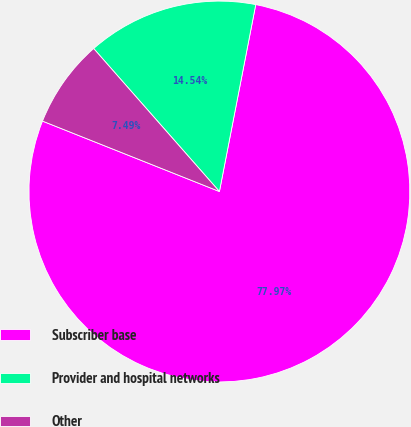<chart> <loc_0><loc_0><loc_500><loc_500><pie_chart><fcel>Subscriber base<fcel>Provider and hospital networks<fcel>Other<nl><fcel>77.98%<fcel>14.54%<fcel>7.49%<nl></chart> 